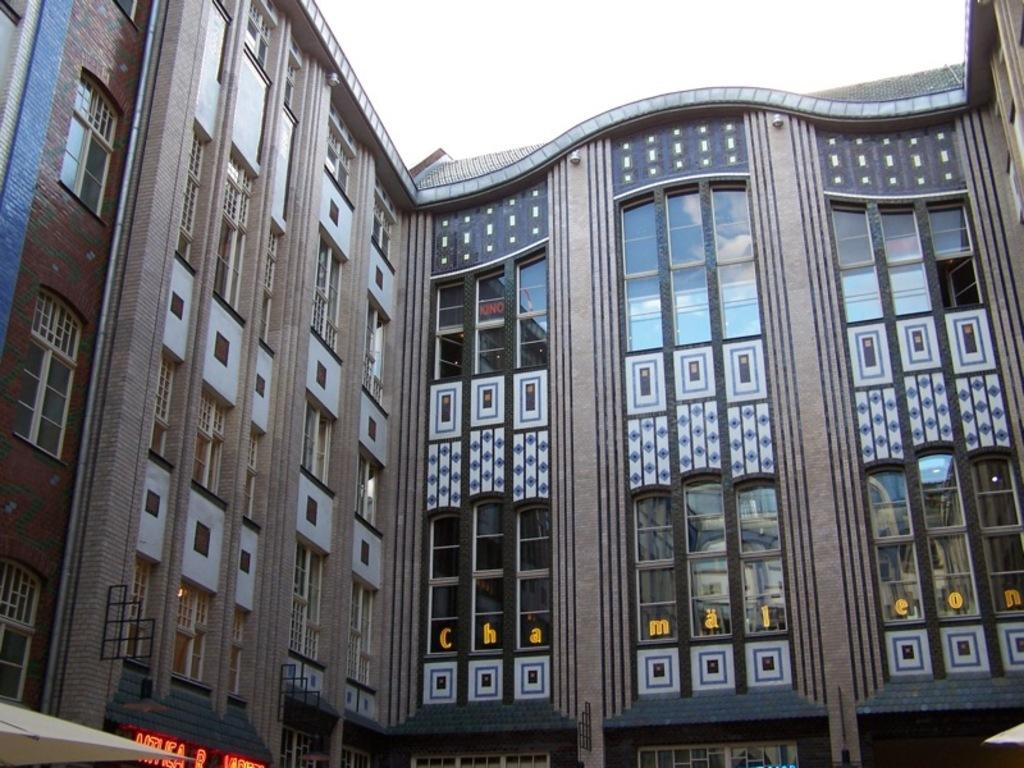What is the main subject of the image? The main subject of the image is a massive building. What can be observed about the building's design? The building has plenty of windows. What type of establishment can be found on the left side of the building? There is a store on the left side of the building. What color is the paint on the aunt's car in the image? There is no aunt or car present in the image, so we cannot determine the color of any paint. 